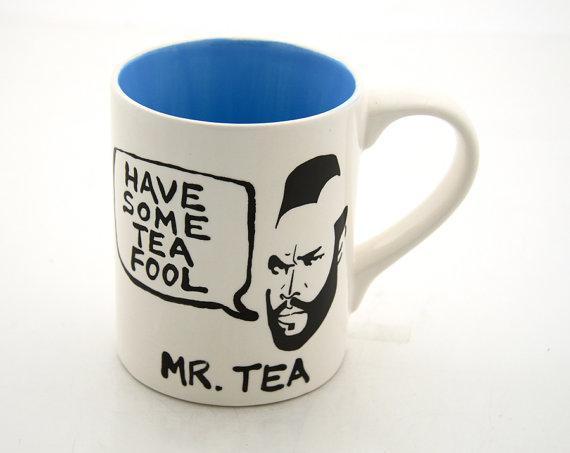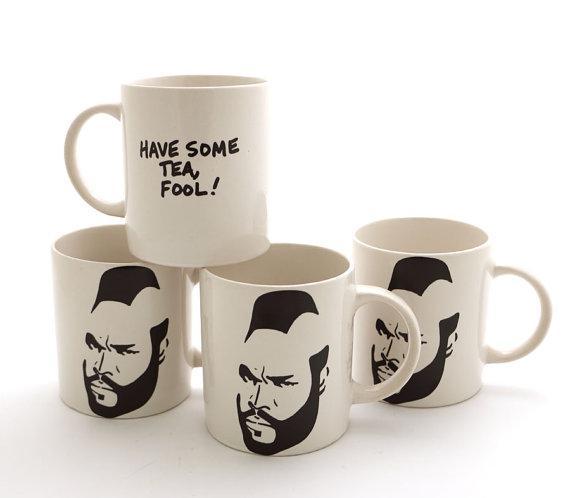The first image is the image on the left, the second image is the image on the right. Assess this claim about the two images: "The combined images contain exactly two mugs, with handles facing opposite directions and a face on each mug.". Correct or not? Answer yes or no. No. The first image is the image on the left, the second image is the image on the right. Given the left and right images, does the statement "One cup is in each image, each decorated with the same person's head, but the cup handles are in opposite directions." hold true? Answer yes or no. No. 